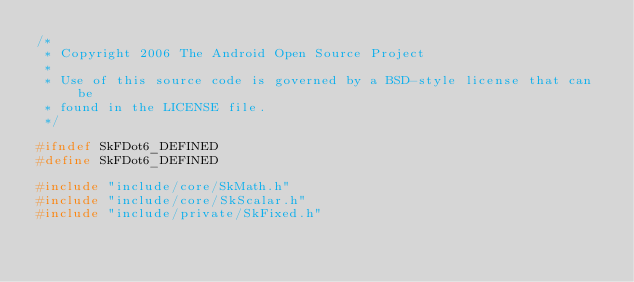Convert code to text. <code><loc_0><loc_0><loc_500><loc_500><_C_>/*
 * Copyright 2006 The Android Open Source Project
 *
 * Use of this source code is governed by a BSD-style license that can be
 * found in the LICENSE file.
 */

#ifndef SkFDot6_DEFINED
#define SkFDot6_DEFINED

#include "include/core/SkMath.h"
#include "include/core/SkScalar.h"
#include "include/private/SkFixed.h"</code> 